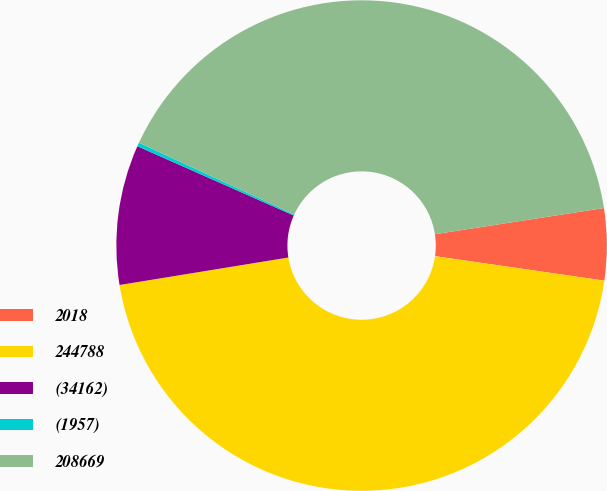<chart> <loc_0><loc_0><loc_500><loc_500><pie_chart><fcel>2018<fcel>244788<fcel>(34162)<fcel>(1957)<fcel>208669<nl><fcel>4.73%<fcel>45.15%<fcel>9.21%<fcel>0.25%<fcel>40.67%<nl></chart> 